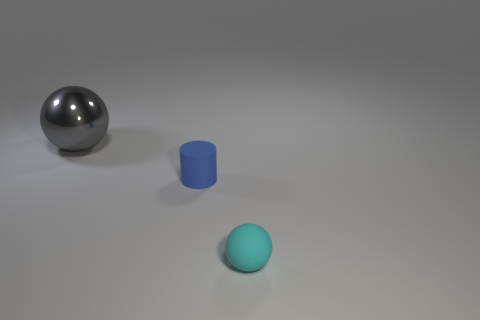What number of shiny objects are small balls or big purple balls?
Offer a very short reply. 0. There is a ball behind the ball in front of the big metal sphere; what is its material?
Offer a terse response. Metal. How many things are either big green spheres or small objects that are to the right of the cylinder?
Provide a short and direct response. 1. What number of brown things are spheres or large shiny spheres?
Ensure brevity in your answer.  0. Are there any other things that have the same material as the gray sphere?
Offer a very short reply. No. There is a large gray metallic object to the left of the matte sphere; does it have the same shape as the small rubber thing on the right side of the blue matte cylinder?
Provide a short and direct response. Yes. What number of yellow rubber spheres are there?
Keep it short and to the point. 0. There is a tiny blue thing that is made of the same material as the cyan thing; what is its shape?
Offer a terse response. Cylinder. Is there anything else that has the same color as the rubber cylinder?
Provide a short and direct response. No. Is the number of cyan spheres to the left of the gray object less than the number of cyan matte spheres?
Offer a terse response. Yes. 